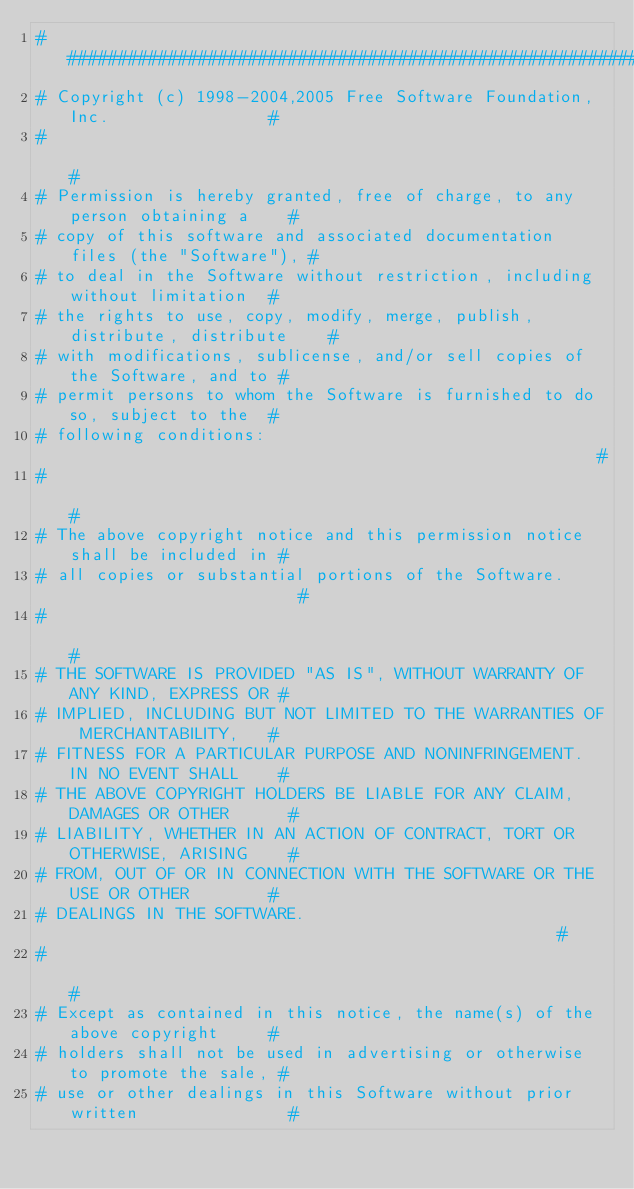<code> <loc_0><loc_0><loc_500><loc_500><_Awk_>##############################################################################
# Copyright (c) 1998-2004,2005 Free Software Foundation, Inc.                #
#                                                                            #
# Permission is hereby granted, free of charge, to any person obtaining a    #
# copy of this software and associated documentation files (the "Software"), #
# to deal in the Software without restriction, including without limitation  #
# the rights to use, copy, modify, merge, publish, distribute, distribute    #
# with modifications, sublicense, and/or sell copies of the Software, and to #
# permit persons to whom the Software is furnished to do so, subject to the  #
# following conditions:                                                      #
#                                                                            #
# The above copyright notice and this permission notice shall be included in #
# all copies or substantial portions of the Software.                        #
#                                                                            #
# THE SOFTWARE IS PROVIDED "AS IS", WITHOUT WARRANTY OF ANY KIND, EXPRESS OR #
# IMPLIED, INCLUDING BUT NOT LIMITED TO THE WARRANTIES OF MERCHANTABILITY,   #
# FITNESS FOR A PARTICULAR PURPOSE AND NONINFRINGEMENT. IN NO EVENT SHALL    #
# THE ABOVE COPYRIGHT HOLDERS BE LIABLE FOR ANY CLAIM, DAMAGES OR OTHER      #
# LIABILITY, WHETHER IN AN ACTION OF CONTRACT, TORT OR OTHERWISE, ARISING    #
# FROM, OUT OF OR IN CONNECTION WITH THE SOFTWARE OR THE USE OR OTHER        #
# DEALINGS IN THE SOFTWARE.                                                  #
#                                                                            #
# Except as contained in this notice, the name(s) of the above copyright     #
# holders shall not be used in advertising or otherwise to promote the sale, #
# use or other dealings in this Software without prior written               #</code> 